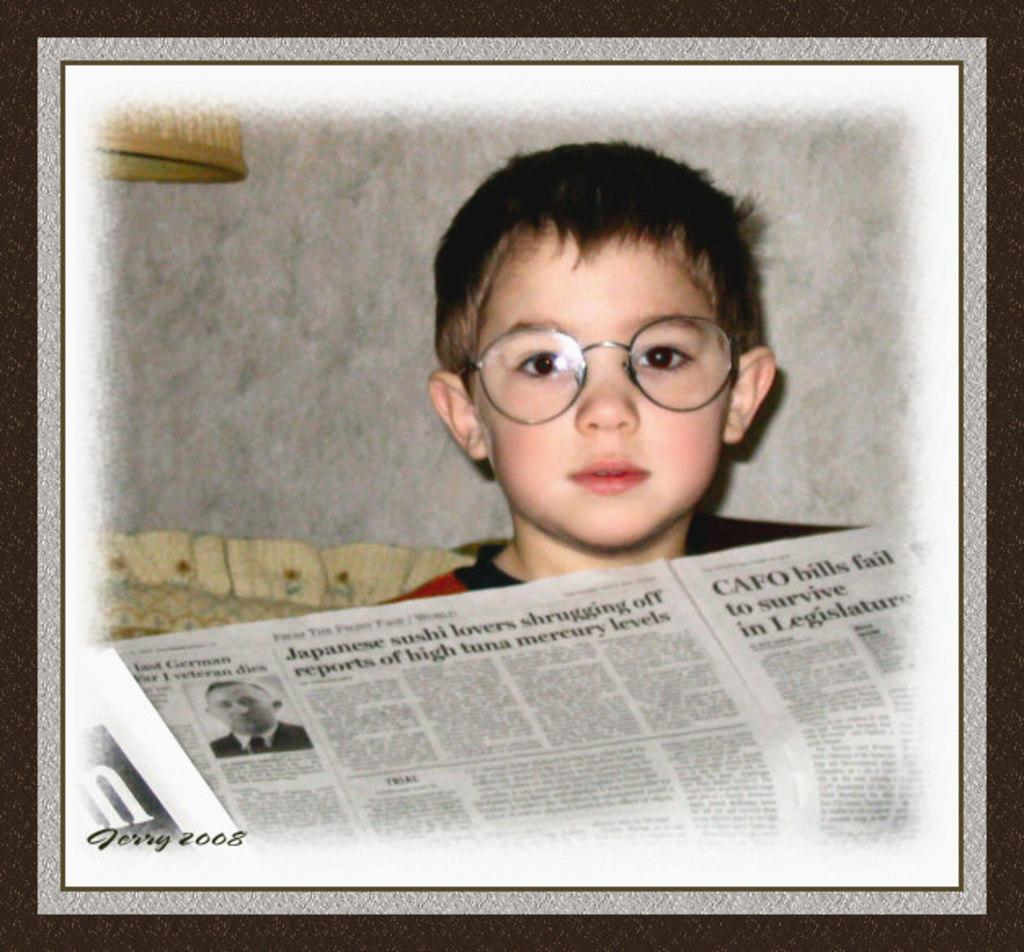Who is present in the image? There is a boy in the image. What is the boy holding in the image? The boy is holding a newspaper in the image. What else can be seen in the image besides the boy and the newspaper? There are objects in the image. Where is the watermark located in the image? The watermark is at the bottom left side of the image. What type of club does the boy use to write on the newspaper in the image? There is no club present in the image, and the boy is not writing on the newspaper. 